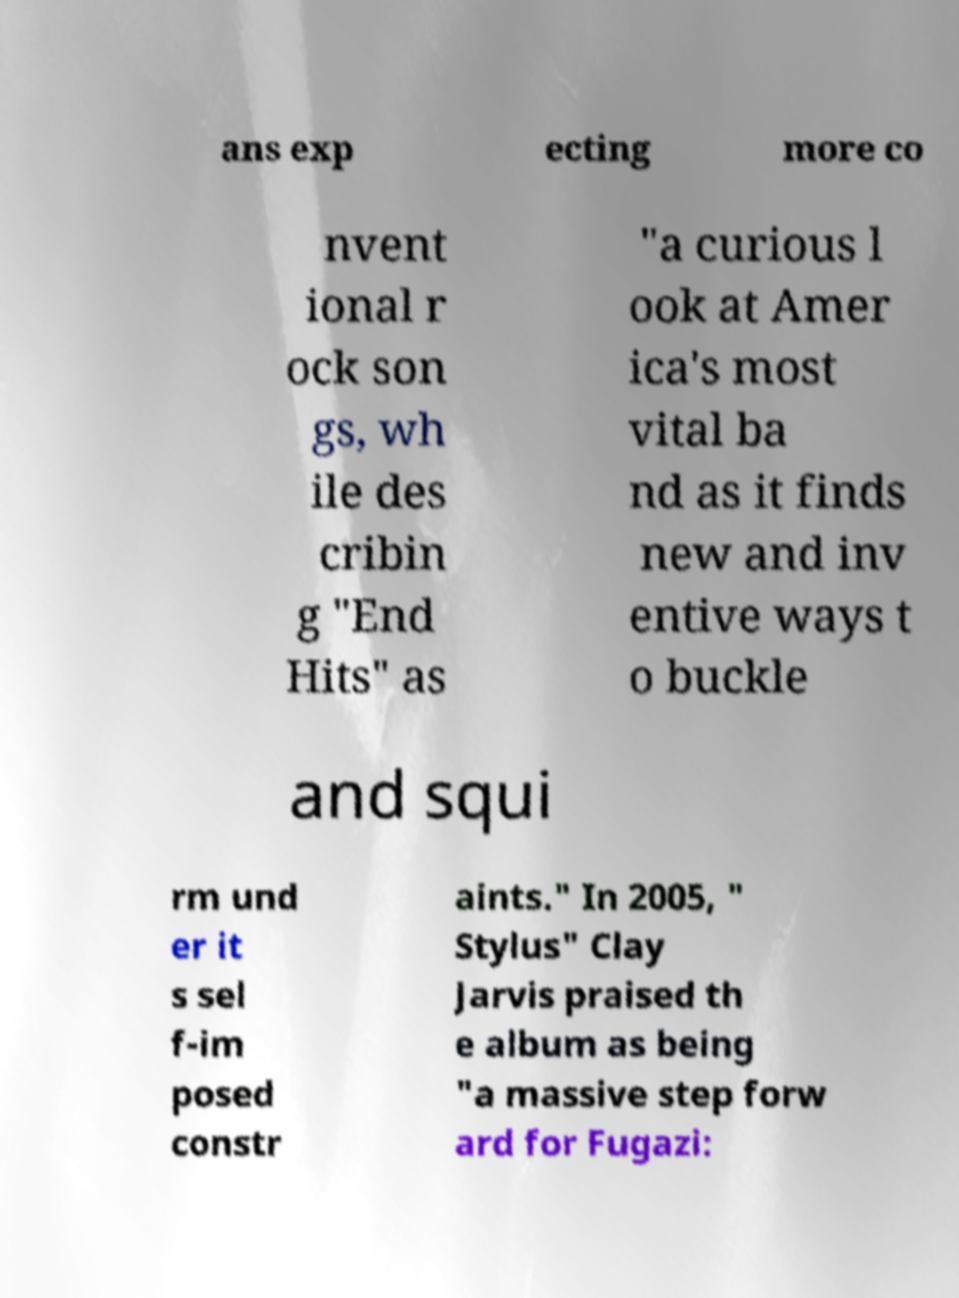Can you accurately transcribe the text from the provided image for me? ans exp ecting more co nvent ional r ock son gs, wh ile des cribin g "End Hits" as "a curious l ook at Amer ica's most vital ba nd as it finds new and inv entive ways t o buckle and squi rm und er it s sel f-im posed constr aints." In 2005, " Stylus" Clay Jarvis praised th e album as being "a massive step forw ard for Fugazi: 